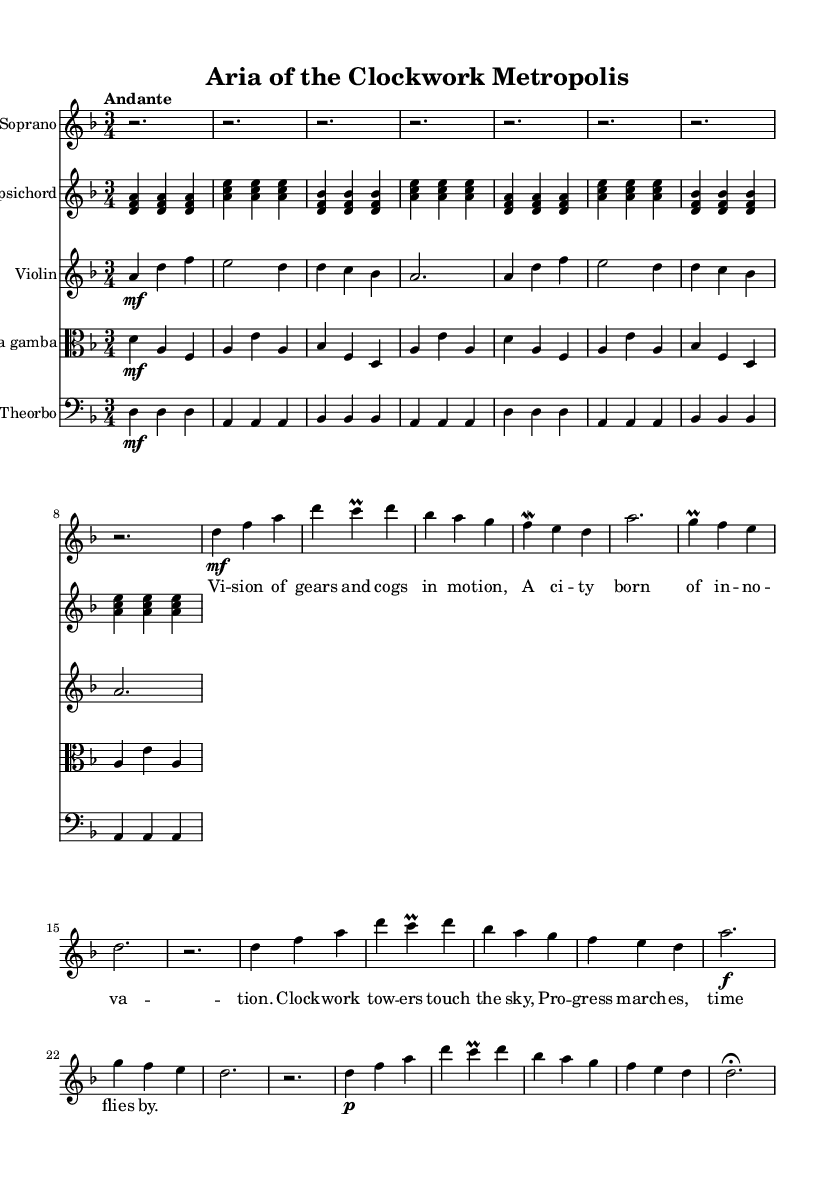What is the key signature of this music? The key signature indicated in the sheet music is two flattened notes, which corresponds to B-flat major or D minor. In this case, the key of D minor is confirmed by analyzing the key signature and the context of the piece.
Answer: D minor What is the time signature of this music? The time signature is represented in the sheet music as a fraction, which shows three beats per measure. This is confirmed by the notation at the beginning of the score.
Answer: 3/4 What is the tempo marking for this piece? The tempo of the piece is identified at the beginning as "Andante," which indicates a moderate walking pace. It conveys the intended speed of the performance.
Answer: Andante How many measures does the introduction comprise? The introduction consists of four measures, as indicated by the notation spacing, with each measure being separated by bar lines, and the content suggesting these rhythmic divisions.
Answer: 4 What role does the theorbo play in this composition? The theorbo serves as a basso continuo instrument, providing harmonic support and a rhythmic bass line, typical in Baroque music. It reinforces the harmonic structure while accompanying the melodic lines above.
Answer: Harmonic support What thematic concept do the lyrics of the aria explore? The lyrics reflect themes of innovation and progress, depicting a futuristic vision of a city characterized by movement and machinery, which aligns with Baroque tendencies to engage with contemporary ideas.
Answer: Innovation and progress How does the structure of the piece reflect traditional Baroque forms? The piece follows a typical Baroque structure with a clear introduction, verses, a ritornello, and a coda, showcasing the use of repetition and contrast, hallmarks of Baroque operas.
Answer: Atypical structure 